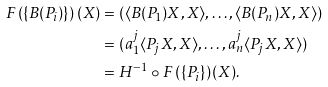<formula> <loc_0><loc_0><loc_500><loc_500>F \left ( \{ B ( P _ { i } ) \} \right ) ( X ) & = ( \langle B ( P _ { 1 } ) X , X \rangle , \dots , \langle B ( P _ { n } ) X , X \rangle ) \\ & = ( a _ { 1 } ^ { j } \langle P _ { j } X , X \rangle , \dots , a _ { n } ^ { j } \langle P _ { j } X , X \rangle ) \\ & = H ^ { - 1 } \circ F \left ( \{ P _ { i } \} \right ) ( X ) .</formula> 